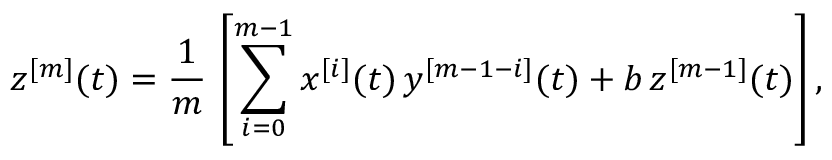Convert formula to latex. <formula><loc_0><loc_0><loc_500><loc_500>z ^ { [ m ] } ( t ) = \frac { 1 } { m } \, \left [ \sum _ { i = 0 } ^ { m - 1 } x ^ { [ i ] } ( t ) \, y ^ { [ m - 1 - i ] } ( t ) + b \, z ^ { [ m - 1 ] } ( t ) \right ] ,</formula> 